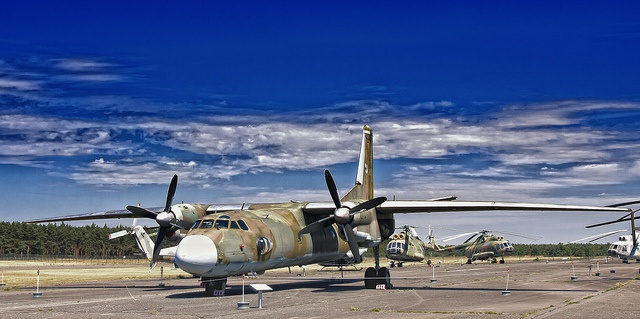Describe the objects in this image and their specific colors. I can see airplane in darkblue, black, gray, darkgray, and lightgray tones, airplane in darkblue, black, gray, darkgray, and ivory tones, airplane in darkblue, black, lightgray, gray, and darkgray tones, and airplane in darkblue, lightgray, darkgray, black, and gray tones in this image. 